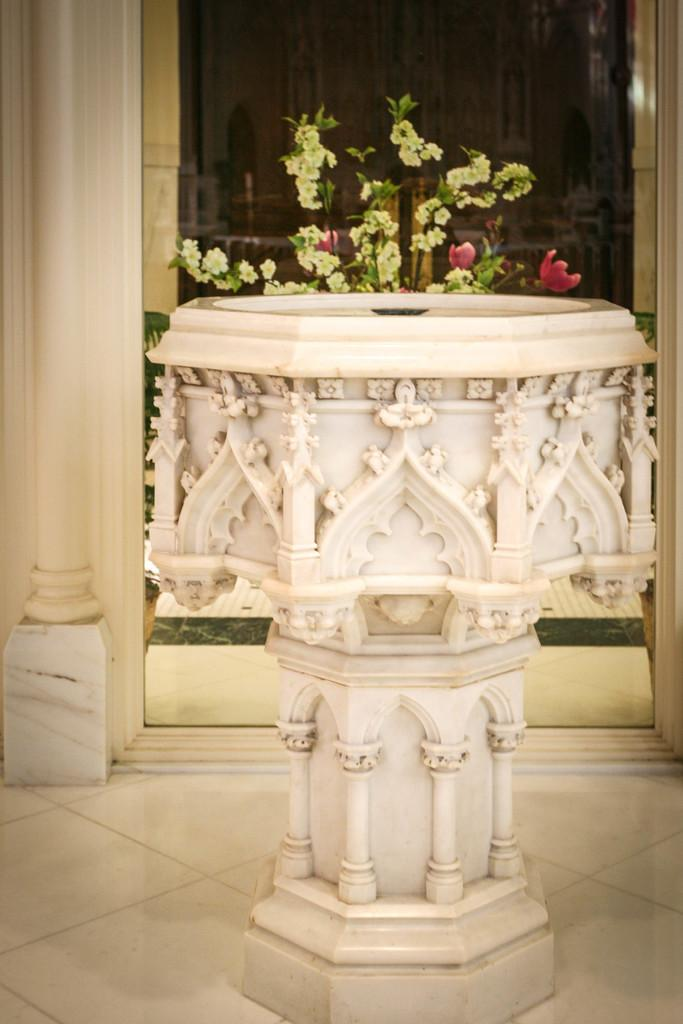What is located in the center of the image? There is a pedestal in the center of the image. What can be seen in the background of the image? There is a plant and a wall in the background of the image. How many eyes can be seen on the pedestal in the image? There are no eyes present on the pedestal or in the image. 